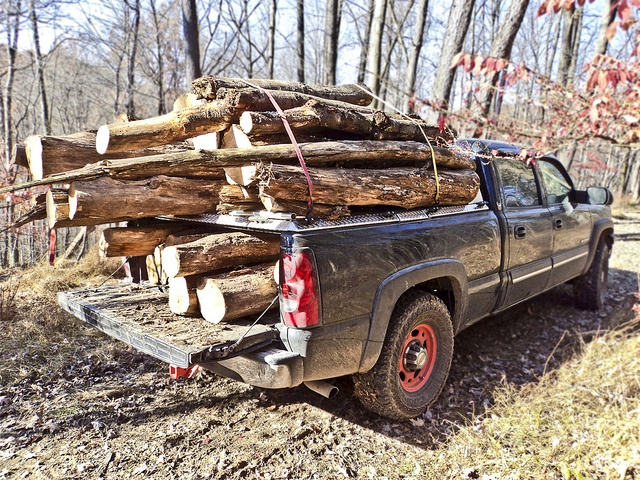Describe the objects in this image and their specific colors. I can see a truck in white, black, gray, maroon, and ivory tones in this image. 